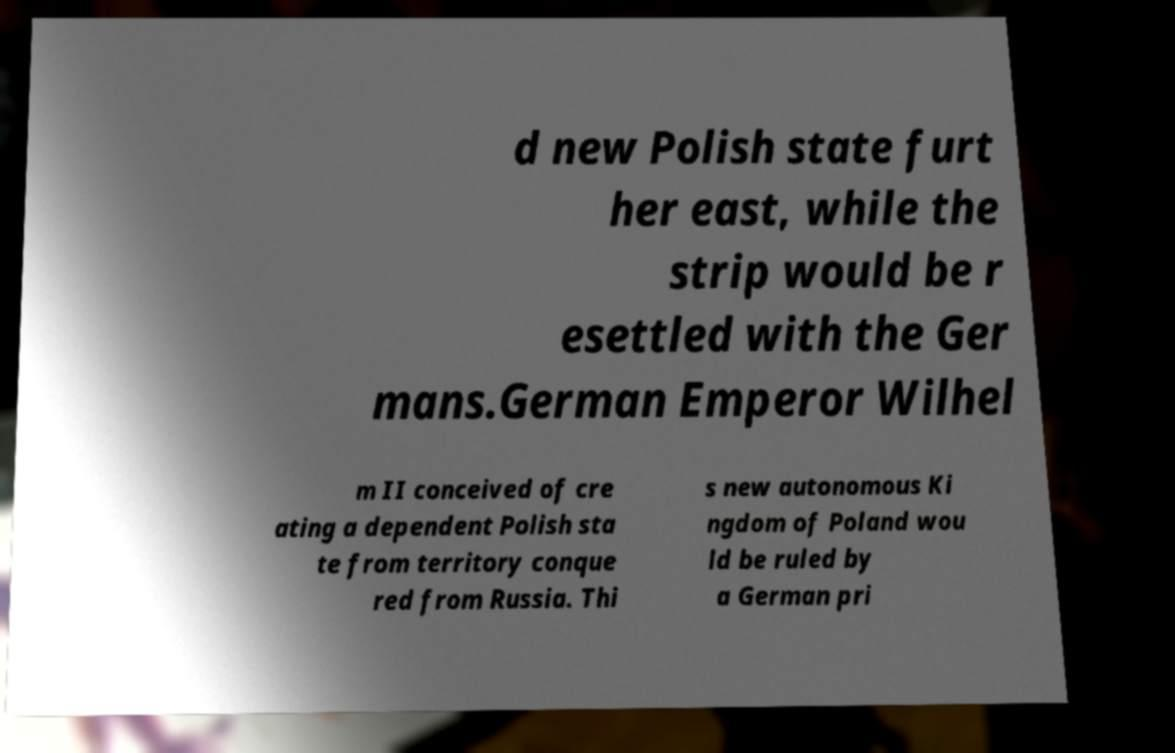There's text embedded in this image that I need extracted. Can you transcribe it verbatim? d new Polish state furt her east, while the strip would be r esettled with the Ger mans.German Emperor Wilhel m II conceived of cre ating a dependent Polish sta te from territory conque red from Russia. Thi s new autonomous Ki ngdom of Poland wou ld be ruled by a German pri 